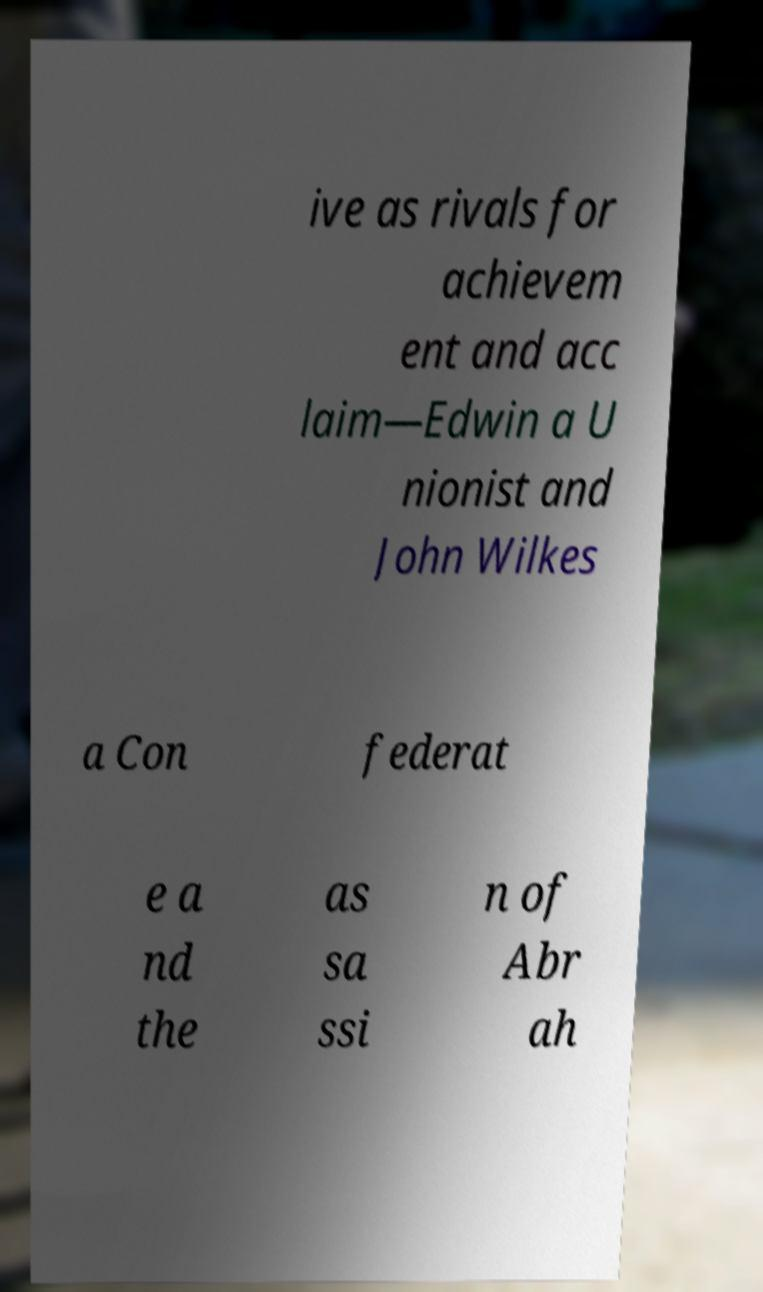I need the written content from this picture converted into text. Can you do that? ive as rivals for achievem ent and acc laim—Edwin a U nionist and John Wilkes a Con federat e a nd the as sa ssi n of Abr ah 